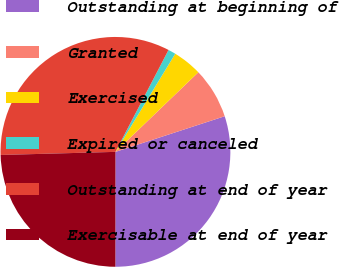Convert chart to OTSL. <chart><loc_0><loc_0><loc_500><loc_500><pie_chart><fcel>Outstanding at beginning of<fcel>Granted<fcel>Exercised<fcel>Expired or canceled<fcel>Outstanding at end of year<fcel>Exercisable at end of year<nl><fcel>30.03%<fcel>7.16%<fcel>4.11%<fcel>1.07%<fcel>33.07%<fcel>24.56%<nl></chart> 